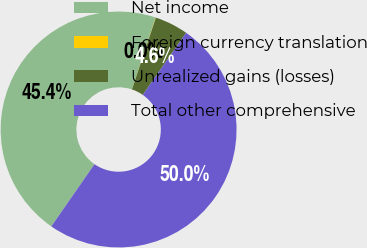Convert chart. <chart><loc_0><loc_0><loc_500><loc_500><pie_chart><fcel>Net income<fcel>Foreign currency translation<fcel>Unrealized gains (losses)<fcel>Total other comprehensive<nl><fcel>45.42%<fcel>0.04%<fcel>4.58%<fcel>49.96%<nl></chart> 